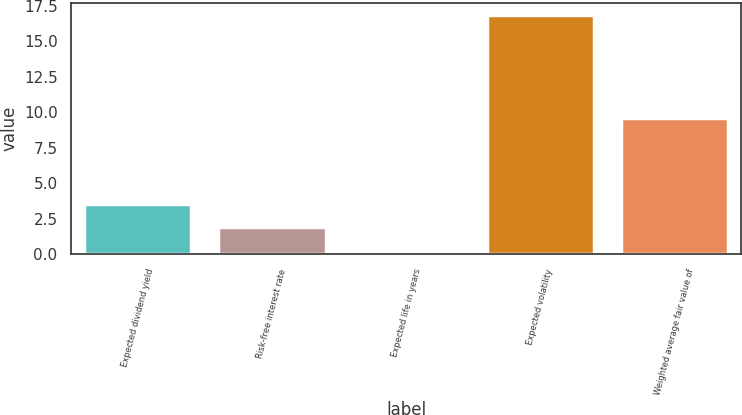<chart> <loc_0><loc_0><loc_500><loc_500><bar_chart><fcel>Expected dividend yield<fcel>Risk-free interest rate<fcel>Expected life in years<fcel>Expected volatility<fcel>Weighted average fair value of<nl><fcel>3.57<fcel>1.91<fcel>0.25<fcel>16.83<fcel>9.56<nl></chart> 